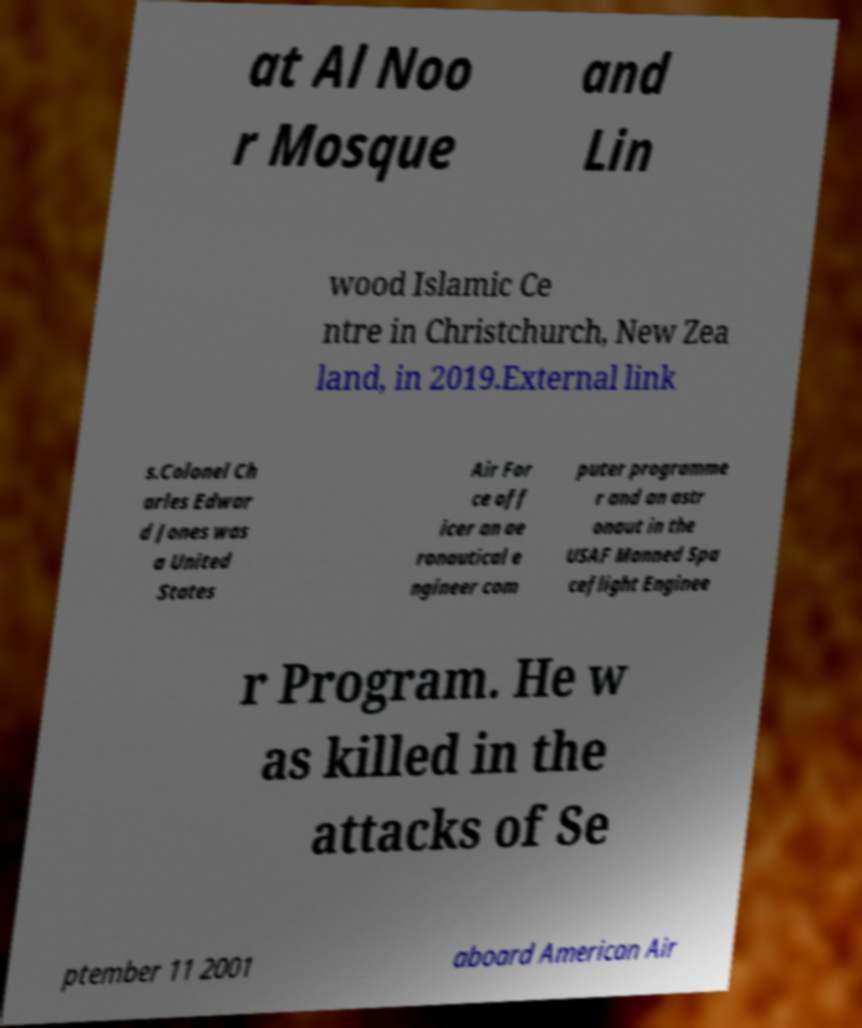I need the written content from this picture converted into text. Can you do that? at Al Noo r Mosque and Lin wood Islamic Ce ntre in Christchurch, New Zea land, in 2019.External link s.Colonel Ch arles Edwar d Jones was a United States Air For ce off icer an ae ronautical e ngineer com puter programme r and an astr onaut in the USAF Manned Spa ceflight Enginee r Program. He w as killed in the attacks of Se ptember 11 2001 aboard American Air 